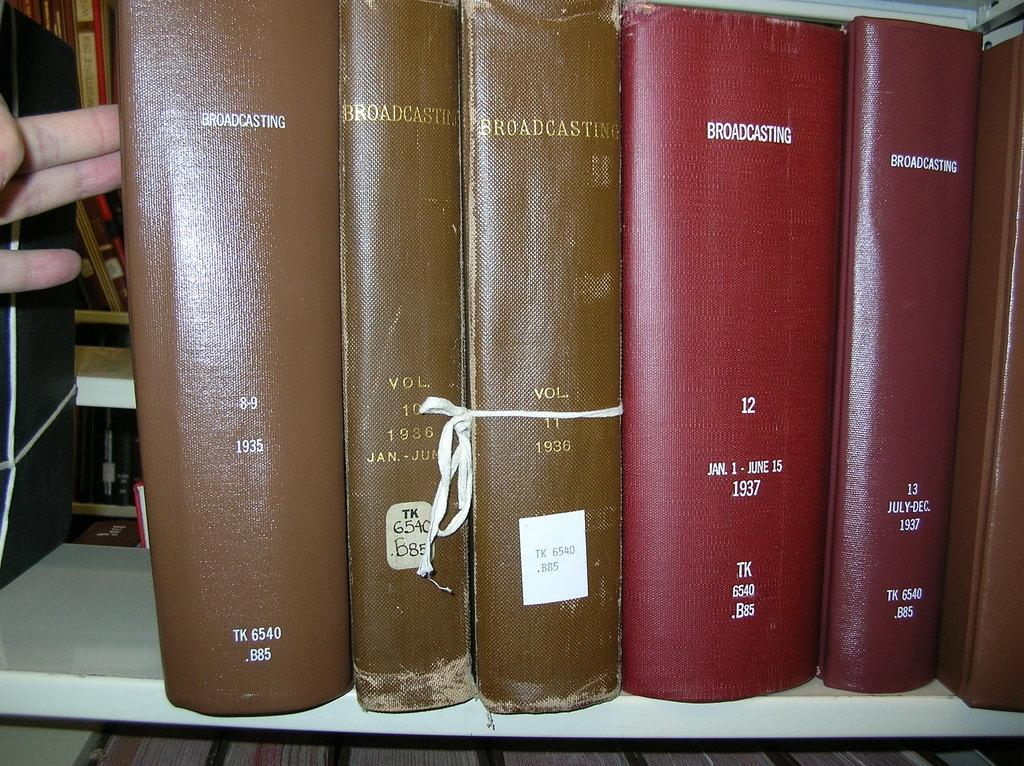Provide a one-sentence caption for the provided image. A thick red book about broadcasting sits on a library shelf. 